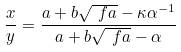<formula> <loc_0><loc_0><loc_500><loc_500>\frac { x } { y } = \frac { a + b \sqrt { \ f a } - \kappa \alpha ^ { - 1 } } { a + b \sqrt { \ f a } - \alpha }</formula> 